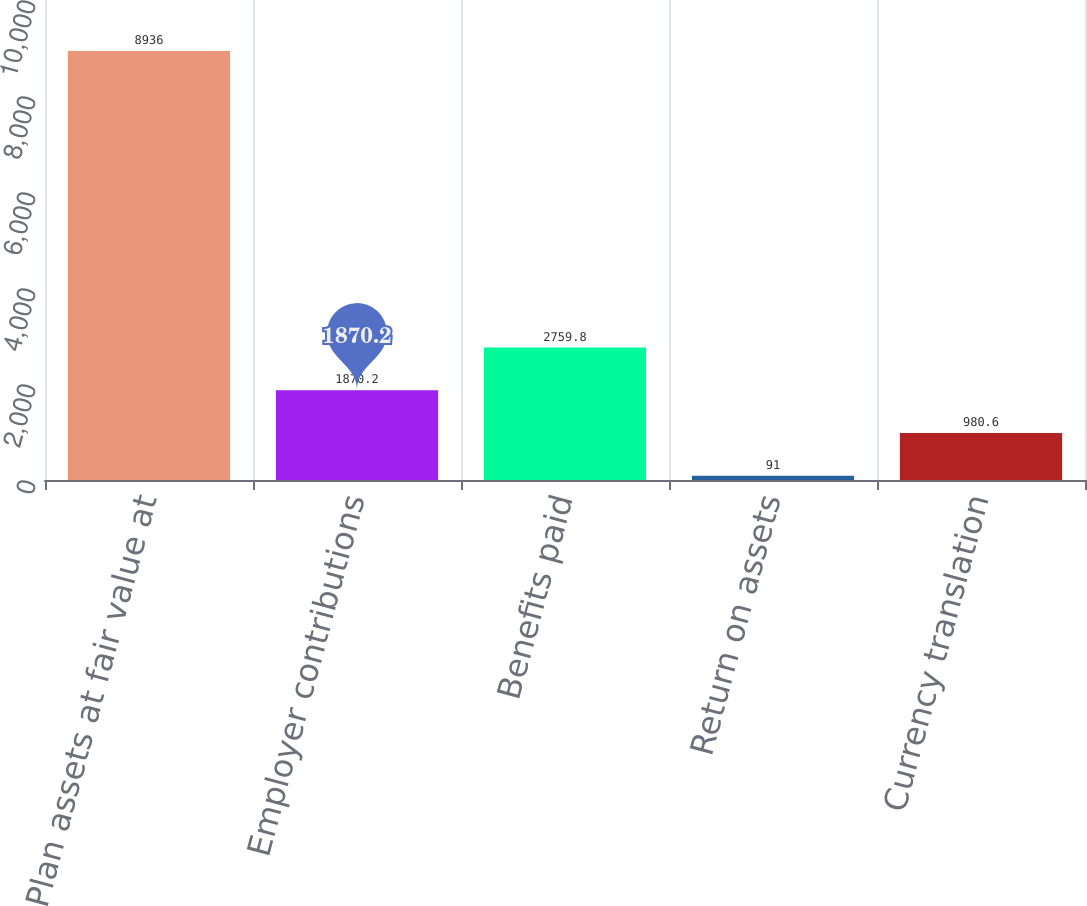Convert chart. <chart><loc_0><loc_0><loc_500><loc_500><bar_chart><fcel>Plan assets at fair value at<fcel>Employer contributions<fcel>Benefits paid<fcel>Return on assets<fcel>Currency translation<nl><fcel>8936<fcel>1870.2<fcel>2759.8<fcel>91<fcel>980.6<nl></chart> 